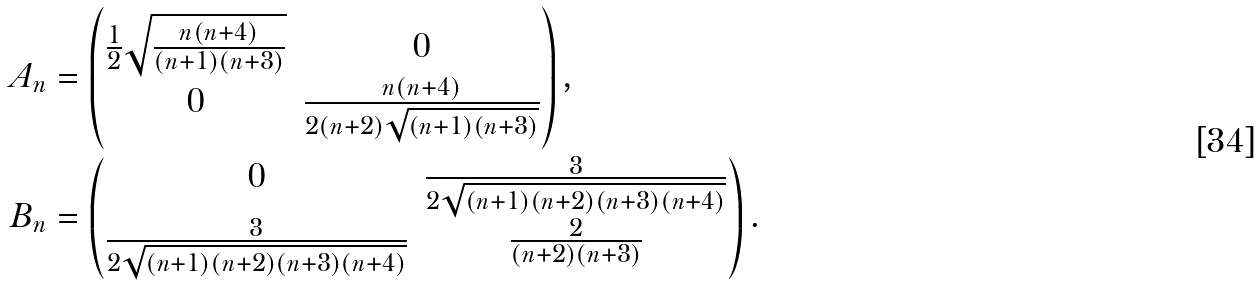Convert formula to latex. <formula><loc_0><loc_0><loc_500><loc_500>A _ { n } & = \begin{pmatrix} \frac { 1 } { 2 } \sqrt { \frac { n ( n + 4 ) } { ( n + 1 ) ( n + 3 ) } } & 0 \\ 0 & \frac { n ( n + 4 ) } { 2 ( n + 2 ) \sqrt { ( n + 1 ) ( n + 3 ) } } \end{pmatrix} , \\ B _ { n } & = \begin{pmatrix} 0 & \frac { 3 } { 2 \sqrt { ( n + 1 ) ( n + 2 ) ( n + 3 ) ( n + 4 ) } } \\ \frac { 3 } { 2 \sqrt { ( n + 1 ) ( n + 2 ) ( n + 3 ) ( n + 4 ) } } & \frac { 2 } { ( n + 2 ) ( n + 3 ) } \end{pmatrix} .</formula> 